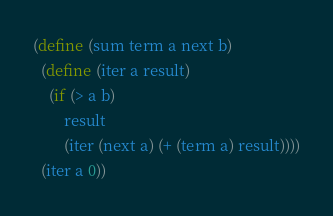<code> <loc_0><loc_0><loc_500><loc_500><_Scheme_>(define (sum term a next b)
  (define (iter a result)
    (if (> a b)
        result
        (iter (next a) (+ (term a) result))))
  (iter a 0))
</code> 